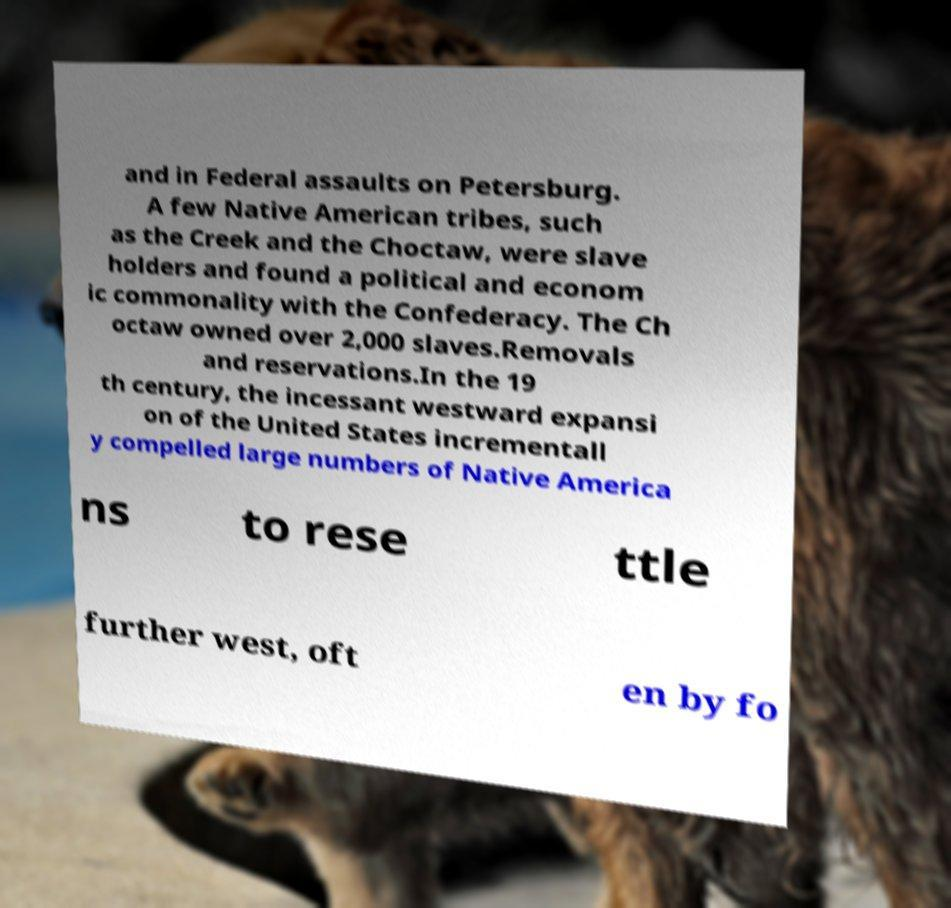Could you assist in decoding the text presented in this image and type it out clearly? and in Federal assaults on Petersburg. A few Native American tribes, such as the Creek and the Choctaw, were slave holders and found a political and econom ic commonality with the Confederacy. The Ch octaw owned over 2,000 slaves.Removals and reservations.In the 19 th century, the incessant westward expansi on of the United States incrementall y compelled large numbers of Native America ns to rese ttle further west, oft en by fo 